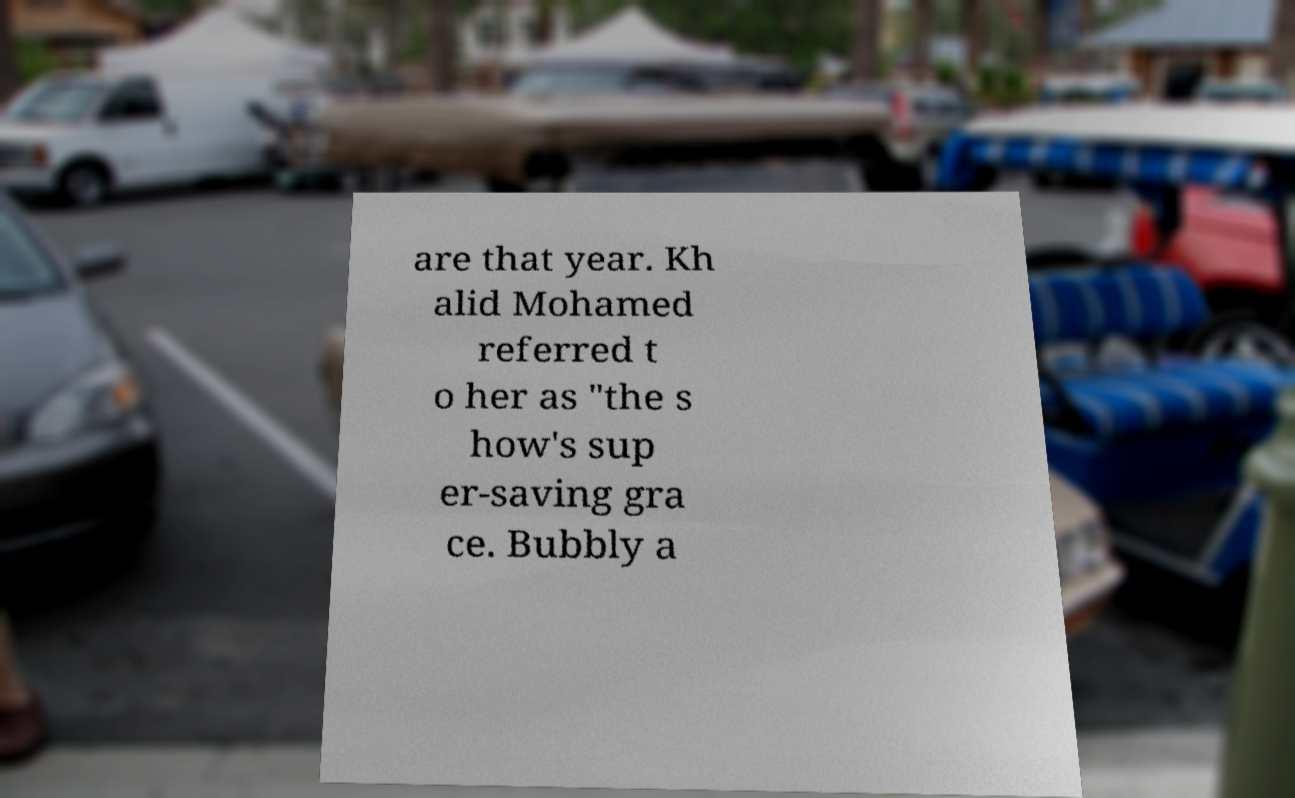Can you read and provide the text displayed in the image?This photo seems to have some interesting text. Can you extract and type it out for me? are that year. Kh alid Mohamed referred t o her as "the s how's sup er-saving gra ce. Bubbly a 